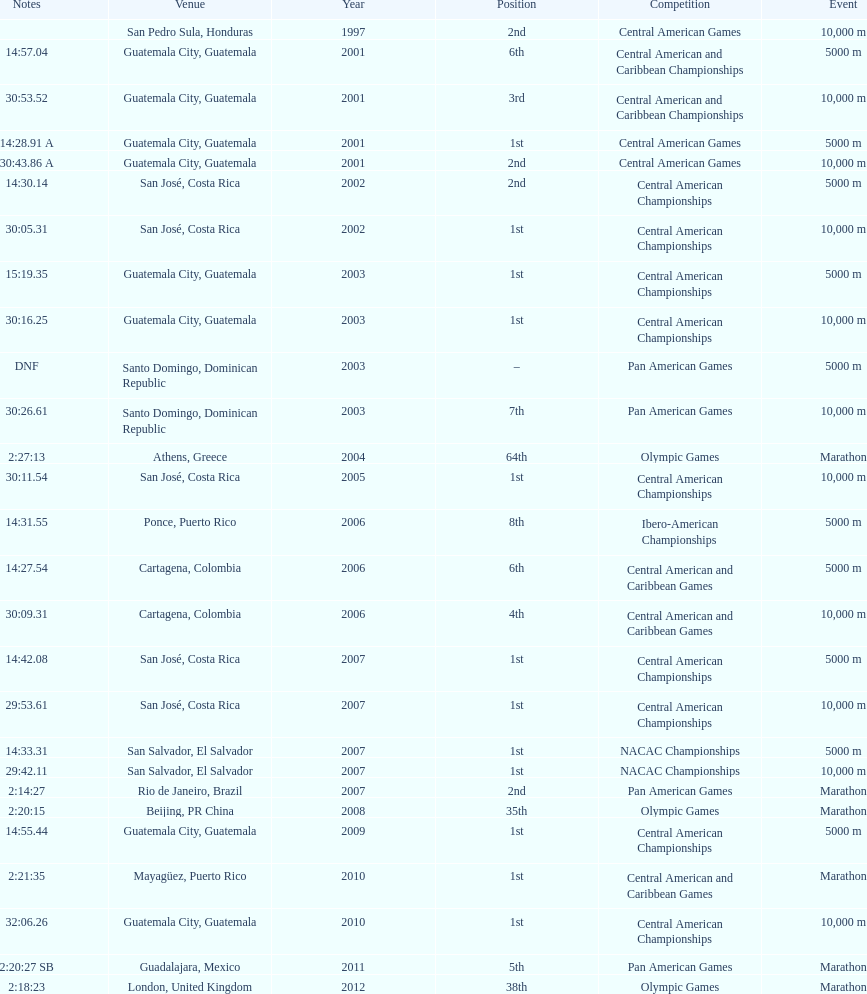How many times has the position of 1st been achieved? 12. Would you be able to parse every entry in this table? {'header': ['Notes', 'Venue', 'Year', 'Position', 'Competition', 'Event'], 'rows': [['', 'San Pedro Sula, Honduras', '1997', '2nd', 'Central American Games', '10,000 m'], ['14:57.04', 'Guatemala City, Guatemala', '2001', '6th', 'Central American and Caribbean Championships', '5000 m'], ['30:53.52', 'Guatemala City, Guatemala', '2001', '3rd', 'Central American and Caribbean Championships', '10,000 m'], ['14:28.91 A', 'Guatemala City, Guatemala', '2001', '1st', 'Central American Games', '5000 m'], ['30:43.86 A', 'Guatemala City, Guatemala', '2001', '2nd', 'Central American Games', '10,000 m'], ['14:30.14', 'San José, Costa Rica', '2002', '2nd', 'Central American Championships', '5000 m'], ['30:05.31', 'San José, Costa Rica', '2002', '1st', 'Central American Championships', '10,000 m'], ['15:19.35', 'Guatemala City, Guatemala', '2003', '1st', 'Central American Championships', '5000 m'], ['30:16.25', 'Guatemala City, Guatemala', '2003', '1st', 'Central American Championships', '10,000 m'], ['DNF', 'Santo Domingo, Dominican Republic', '2003', '–', 'Pan American Games', '5000 m'], ['30:26.61', 'Santo Domingo, Dominican Republic', '2003', '7th', 'Pan American Games', '10,000 m'], ['2:27:13', 'Athens, Greece', '2004', '64th', 'Olympic Games', 'Marathon'], ['30:11.54', 'San José, Costa Rica', '2005', '1st', 'Central American Championships', '10,000 m'], ['14:31.55', 'Ponce, Puerto Rico', '2006', '8th', 'Ibero-American Championships', '5000 m'], ['14:27.54', 'Cartagena, Colombia', '2006', '6th', 'Central American and Caribbean Games', '5000 m'], ['30:09.31', 'Cartagena, Colombia', '2006', '4th', 'Central American and Caribbean Games', '10,000 m'], ['14:42.08', 'San José, Costa Rica', '2007', '1st', 'Central American Championships', '5000 m'], ['29:53.61', 'San José, Costa Rica', '2007', '1st', 'Central American Championships', '10,000 m'], ['14:33.31', 'San Salvador, El Salvador', '2007', '1st', 'NACAC Championships', '5000 m'], ['29:42.11', 'San Salvador, El Salvador', '2007', '1st', 'NACAC Championships', '10,000 m'], ['2:14:27', 'Rio de Janeiro, Brazil', '2007', '2nd', 'Pan American Games', 'Marathon'], ['2:20:15', 'Beijing, PR China', '2008', '35th', 'Olympic Games', 'Marathon'], ['14:55.44', 'Guatemala City, Guatemala', '2009', '1st', 'Central American Championships', '5000 m'], ['2:21:35', 'Mayagüez, Puerto Rico', '2010', '1st', 'Central American and Caribbean Games', 'Marathon'], ['32:06.26', 'Guatemala City, Guatemala', '2010', '1st', 'Central American Championships', '10,000 m'], ['2:20:27 SB', 'Guadalajara, Mexico', '2011', '5th', 'Pan American Games', 'Marathon'], ['2:18:23', 'London, United Kingdom', '2012', '38th', 'Olympic Games', 'Marathon']]} 